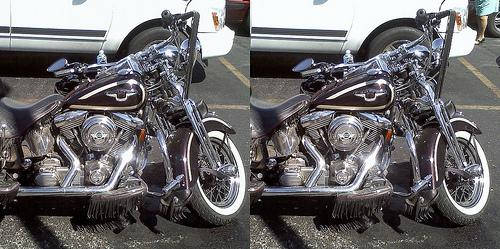Question: what kind of bike is in the picture?
Choices:
A. A bicycle.
B. A tricycle.
C. A unicycle.
D. A motorcycle.
Answer with the letter. Answer: D Question: how many people can ride this bike safely?
Choices:
A. Two people can ride safely.
B. One person can ride safely.
C. Three people can ride safely.
D. Four people can ride safely.
Answer with the letter. Answer: B Question: what color is the woman's shorts?
Choices:
A. Her shorts are blue.
B. Her shorts are green.
C. Her shorts are red.
D. Her shorts are orange.
Answer with the letter. Answer: B Question: what color is the bike?
Choices:
A. The bike is blue.
B. The bike is black.
C. The bike is green.
D. The bike is orange.
Answer with the letter. Answer: B Question: when do you call motorcycle antique?
Choices:
A. When it is broken.
B. When it is old.
C. When it is rusty.
D. When it is ugly.
Answer with the letter. Answer: B 